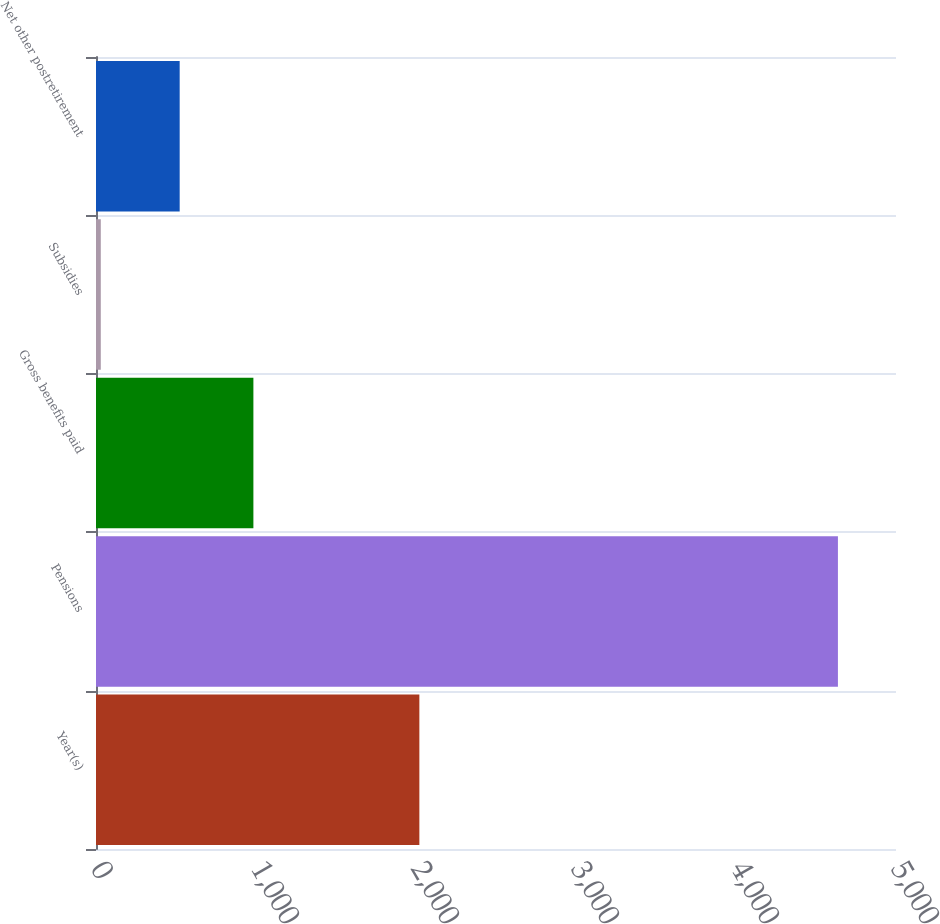Convert chart. <chart><loc_0><loc_0><loc_500><loc_500><bar_chart><fcel>Year(s)<fcel>Pensions<fcel>Gross benefits paid<fcel>Subsidies<fcel>Net other postretirement<nl><fcel>2021<fcel>4637<fcel>983.7<fcel>30<fcel>523<nl></chart> 